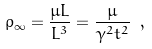Convert formula to latex. <formula><loc_0><loc_0><loc_500><loc_500>\rho _ { \infty } = \frac { \mu L } { L ^ { 3 } } = \frac { \mu } { \gamma ^ { 2 } t ^ { 2 } } \ ,</formula> 